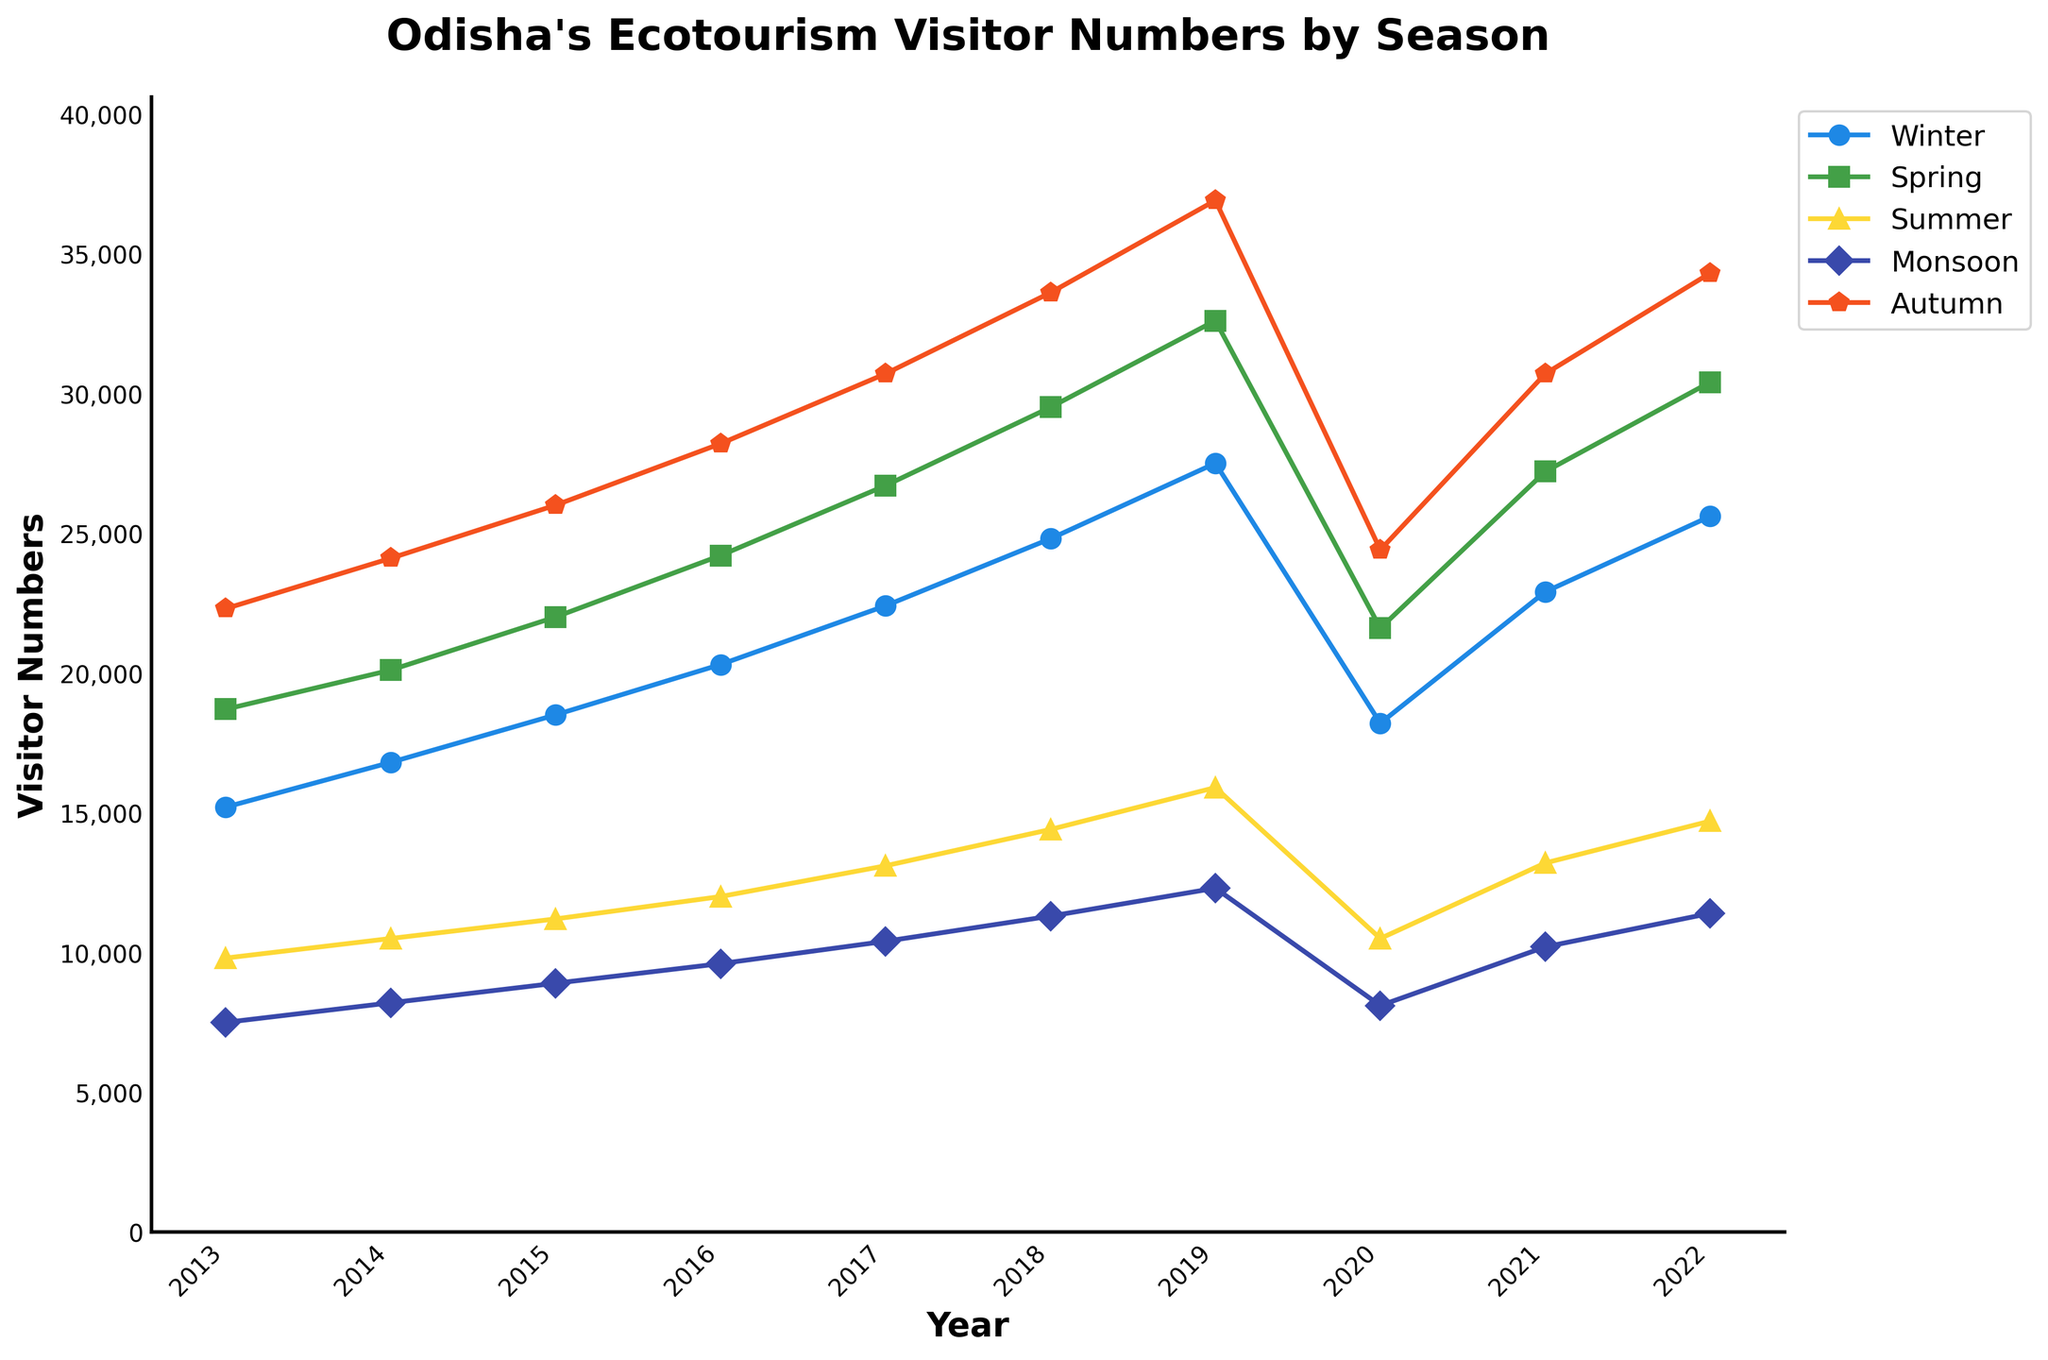Which season had the highest number of visitors in 2022? Look at the year 2022 and compare the visitor numbers for each season to find the highest value. The highest visitor number in 2022 is in Autumn.
Answer: Autumn Which year had the lowest number of visitors during the Monsoon season? Compare the visitor numbers for the Monsoon season across all the years and identify the lowest value. The lowest number of visitors during the Monsoon season was in 2013.
Answer: 2013 What was the total number of visitors in 2018 across all seasons? Sum the visitor numbers for all seasons in the year 2018: Winter (24800) + Spring (29500) + Summer (14400) + Monsoon (11300) + Autumn (33600) = 113600
Answer: 113600 Which season had the steadiest increase in visitors from 2013 to 2022? Look at all the seasons and observe the trend of changes in visitor numbers over the years. Winter shows a consistent upward trend without any sharp decreases.
Answer: Winter In which year did Spring have more visitors than Winter? For each year, compare the visitor numbers in Spring and Winter and identify the years where Spring had more visitors. Spring had more visitors than Winter in 2019.
Answer: 2019 Which two seasons had the closest number of visitors in 2021? Compare the visitor numbers for all seasons in 2021 and identify the two seasons with the smallest difference. Spring (27200) and Autumn (30700) have the closest visitor numbers.
Answer: Spring and Autumn What was the average number of visitors in Summer over the decade? Sum the visitor numbers for Summer from 2013 to 2022 and divide by the number of years: (9800 + 10500 + 11200 + 12000 + 13100 + 14400 + 15900 + 10500 + 13200 + 14700) / 10 = 12530
Answer: 12530 Did the Monsoon season ever have more visitors than the Summer season? Compare the visitor numbers for the Monsoon and Summer seasons for each year and check if any year has Monsoon visitor numbers higher than Summer visitor numbers. In none of the years did Monsoon have more visitors than Summer.
Answer: No By how much did the number of visitors in Winter increase from 2013 to 2022? Subtract the number of visitors in Winter in 2013 from the number in 2022: 25600 - 15200 = 10400
Answer: 10400 Which year experienced a drop in the number of visitors compared to the previous year? Compare the visitor numbers in each year with the previous year for each season. The year 2020 experienced a drop compared to 2019.
Answer: 2020 